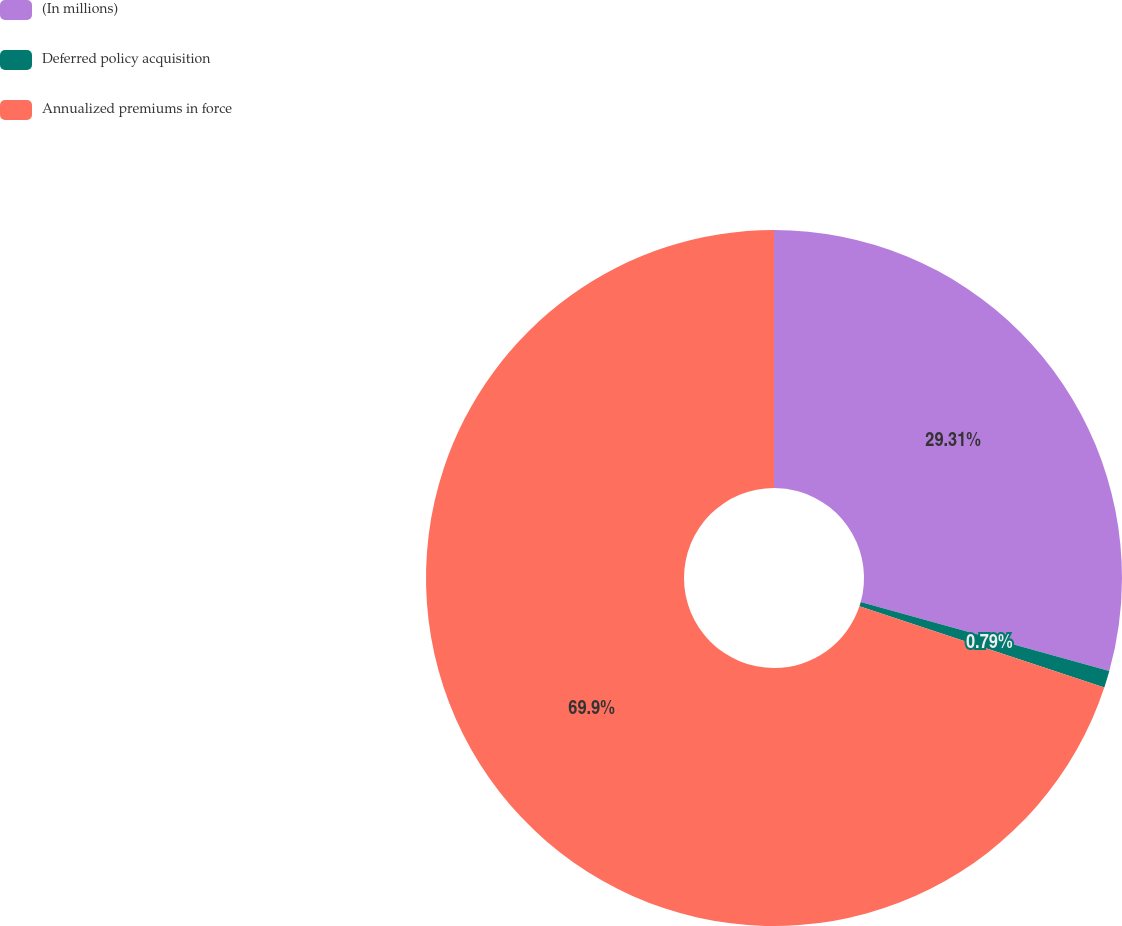<chart> <loc_0><loc_0><loc_500><loc_500><pie_chart><fcel>(In millions)<fcel>Deferred policy acquisition<fcel>Annualized premiums in force<nl><fcel>29.31%<fcel>0.79%<fcel>69.9%<nl></chart> 